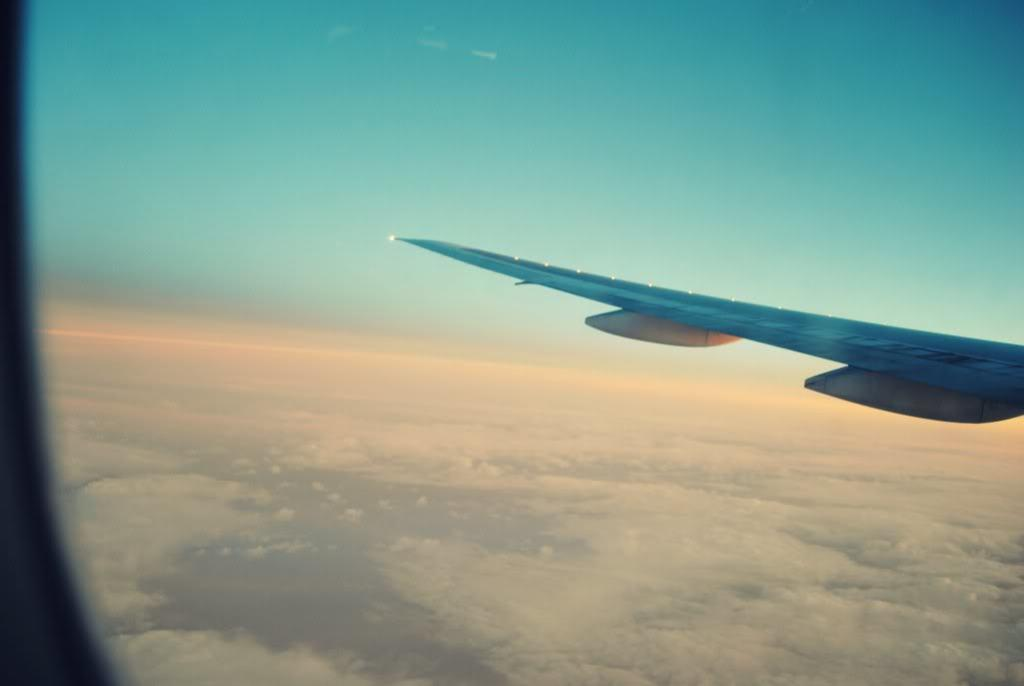What is the main subject of the image? The main subject of the image is a plane. What can be seen in the background of the image? The sky is visible in the image. What type of hand is shown holding the plane in the image? There is no hand holding the plane in the image; it is not present. 